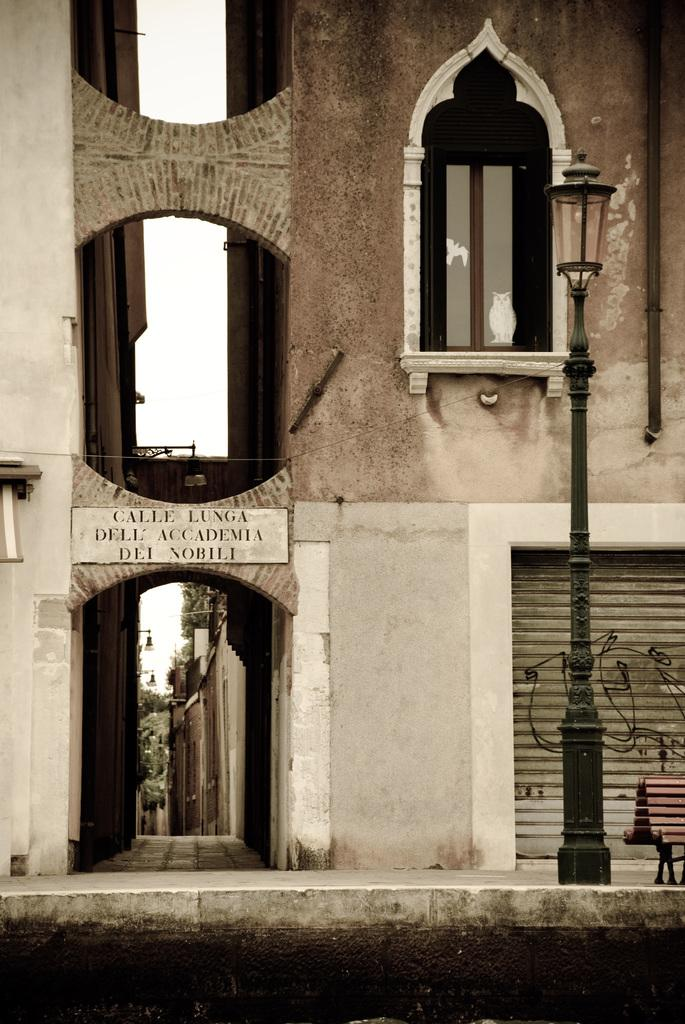What type of structure is visible in the image? There is a building in the image. What features can be seen on the building? The building has windows and a shutter. What is located at the bottom of the image? There is a pavement at the bottom of the image. What object is on the pavement? There is a pole on the pavement. What is attached to the building in the front? There is a board on the building in the front. Can you tell me how many rabbits are sitting on the knee of the person in the image? There is no person or rabbit present in the image. What type of wash is being done on the building in the image? There is no wash being done on the building in the image. 